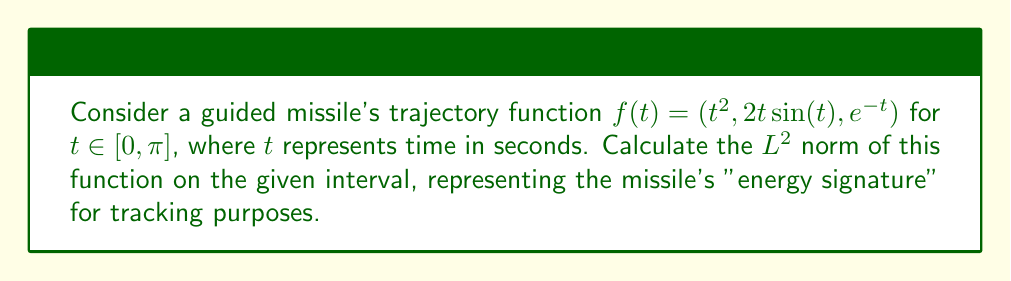Solve this math problem. To calculate the $L^2$ norm of the function $f(t) = (t^2, 2t\sin(t), e^{-t})$ on the interval $[0, \pi]$, we follow these steps:

1) The $L^2$ norm of a vector-valued function $f(t) = (f_1(t), f_2(t), f_3(t))$ on an interval $[a,b]$ is given by:

   $$\|f\|_2 = \sqrt{\int_a^b (f_1(t)^2 + f_2(t)^2 + f_3(t)^2) dt}$$

2) In our case, $f_1(t) = t^2$, $f_2(t) = 2t\sin(t)$, and $f_3(t) = e^{-t}$. We need to calculate:

   $$\|f\|_2 = \sqrt{\int_0^\pi (t^4 + 4t^2\sin^2(t) + e^{-2t}) dt}$$

3) Let's evaluate each term separately:

   a) $\int_0^\pi t^4 dt = \frac{t^5}{5}\Big|_0^\pi = \frac{\pi^5}{5}$

   b) $\int_0^\pi 4t^2\sin^2(t) dt$:
      This is a complex integral. We can use the identity $\sin^2(t) = \frac{1-\cos(2t)}{2}$:
      $$\int_0^\pi 4t^2\sin^2(t) dt = \int_0^\pi 2t^2 dt - \int_0^\pi 2t^2\cos(2t) dt$$
      $$= \frac{2\pi^3}{3} - \left[t^2\sin(2t) + t\cos(2t) - \frac{1}{2}\sin(2t)\right]_0^\pi$$
      $$= \frac{2\pi^3}{3} - (\pi^2\sin(2\pi) + \pi\cos(2\pi) - \frac{1}{2}\sin(2\pi)) + 0$$
      $$= \frac{2\pi^3}{3} + \pi$$

   c) $\int_0^\pi e^{-2t} dt = -\frac{1}{2}e^{-2t}\Big|_0^\pi = -\frac{1}{2}(e^{-2\pi} - 1)$

4) Summing these results:

   $$\|f\|_2^2 = \frac{\pi^5}{5} + \frac{2\pi^3}{3} + \pi - \frac{1}{2}(e^{-2\pi} - 1)$$

5) Taking the square root:

   $$\|f\|_2 = \sqrt{\frac{\pi^5}{5} + \frac{2\pi^3}{3} + \pi - \frac{1}{2}(e^{-2\pi} - 1)}$$
Answer: $$\|f\|_2 = \sqrt{\frac{\pi^5}{5} + \frac{2\pi^3}{3} + \pi - \frac{1}{2}(e^{-2\pi} - 1)} \approx 5.013$$ 